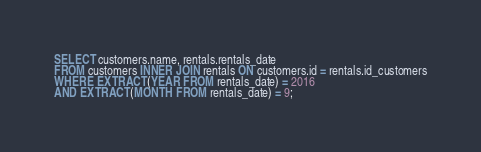Convert code to text. <code><loc_0><loc_0><loc_500><loc_500><_SQL_>SELECT customers.name, rentals.rentals_date
FROM customers INNER JOIN rentals ON customers.id = rentals.id_customers
WHERE EXTRACT(YEAR FROM rentals_date) = 2016
AND EXTRACT(MONTH FROM rentals_date) = 9;</code> 